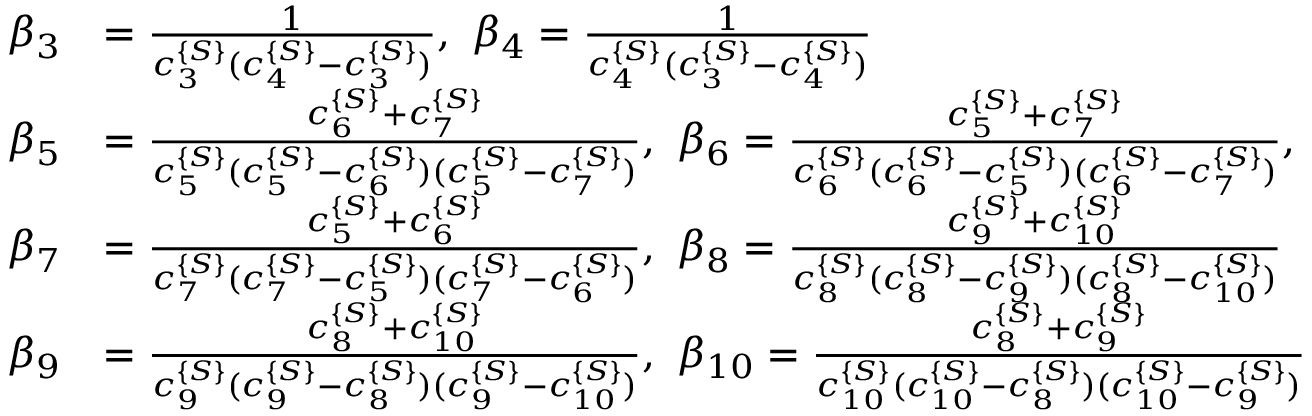Convert formula to latex. <formula><loc_0><loc_0><loc_500><loc_500>\begin{array} { r l } { \beta _ { 3 } } & { = \frac { 1 } { c _ { 3 } ^ { \{ S \} } ( c _ { 4 } ^ { \{ S \} } - c _ { 3 } ^ { \{ S \} } ) } , \ \beta _ { 4 } = \frac { 1 } { c _ { 4 } ^ { \{ S \} } ( c _ { 3 } ^ { \{ S \} } - c _ { 4 } ^ { \{ S \} } ) } } \\ { \beta _ { 5 } } & { = \frac { c _ { 6 } ^ { \{ S \} } + c _ { 7 } ^ { \{ S \} } } { c _ { 5 } ^ { \{ S \} } ( c _ { 5 } ^ { \{ S \} } - c _ { 6 } ^ { \{ S \} } ) ( c _ { 5 } ^ { \{ S \} } - c _ { 7 } ^ { \{ S \} } ) } , \ \beta _ { 6 } = \frac { c _ { 5 } ^ { \{ S \} } + c _ { 7 } ^ { \{ S \} } } { c _ { 6 } ^ { \{ S \} } ( c _ { 6 } ^ { \{ S \} } - c _ { 5 } ^ { \{ S \} } ) ( c _ { 6 } ^ { \{ S \} } - c _ { 7 } ^ { \{ S \} } ) } , } \\ { \beta _ { 7 } } & { = \frac { c _ { 5 } ^ { \{ S \} } + c _ { 6 } ^ { \{ S \} } } { c _ { 7 } ^ { \{ S \} } ( c _ { 7 } ^ { \{ S \} } - c _ { 5 } ^ { \{ S \} } ) ( c _ { 7 } ^ { \{ S \} } - c _ { 6 } ^ { \{ S \} } ) } , \ \beta _ { 8 } = \frac { c _ { 9 } ^ { \{ S \} } + c _ { 1 0 } ^ { \{ S \} } } { c _ { 8 } ^ { \{ S \} } ( c _ { 8 } ^ { \{ S \} } - c _ { 9 } ^ { \{ S \} } ) ( c _ { 8 } ^ { \{ S \} } - c _ { 1 0 } ^ { \{ S \} } ) } } \\ { \beta _ { 9 } } & { = \frac { c _ { 8 } ^ { \{ S \} } + c _ { 1 0 } ^ { \{ S \} } } { c _ { 9 } ^ { \{ S \} } ( c _ { 9 } ^ { \{ S \} } - c _ { 8 } ^ { \{ S \} } ) ( c _ { 9 } ^ { \{ S \} } - c _ { 1 0 } ^ { \{ S \} } ) } , \ \beta _ { 1 0 } = \frac { c _ { 8 } ^ { \{ S \} } + c _ { 9 } ^ { \{ S \} } } { c _ { 1 0 } ^ { \{ S \} } ( c _ { 1 0 } ^ { \{ S \} } - c _ { 8 } ^ { \{ S \} } ) ( c _ { 1 0 } ^ { \{ S \} } - c _ { 9 } ^ { \{ S \} } ) } } \end{array}</formula> 